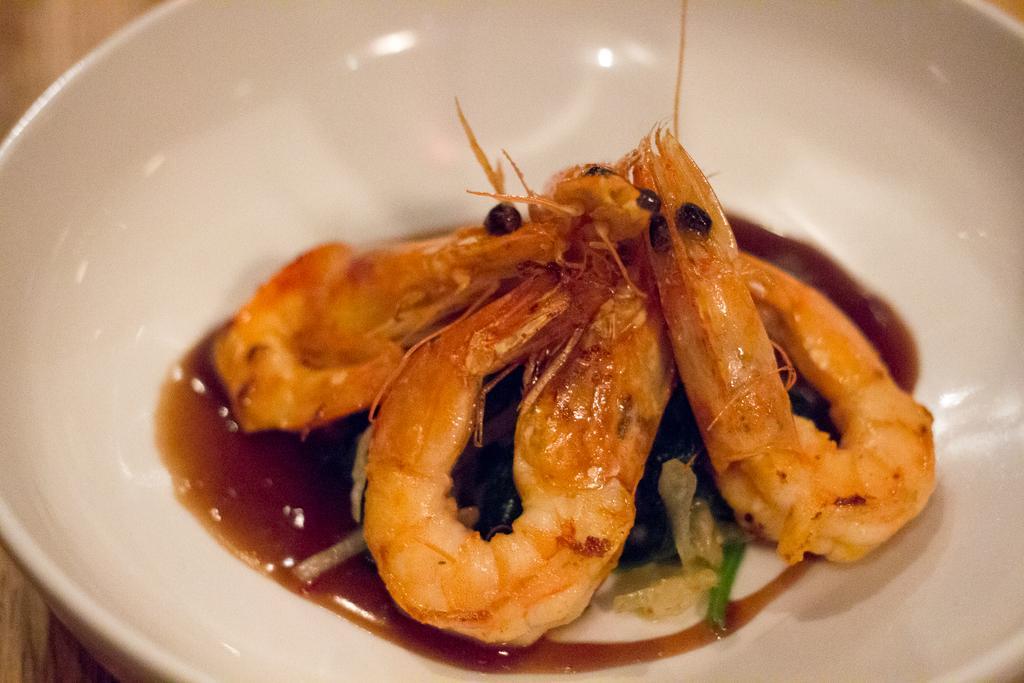Please provide a concise description of this image. In this image I can see food items in a white color bowl. This bowl is on a wooden surface. 